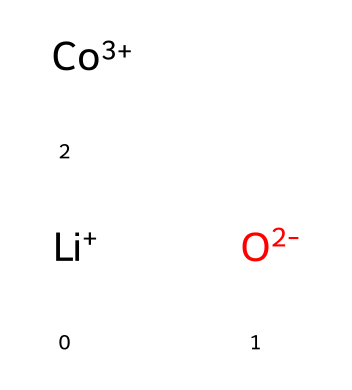What is the total charge of lithium cobalt oxide? The chemical representation indicates lithium as Li+ (1+), cobalt as Co+3 (3+), and oxygen as O-2 (2-). Therefore, the total charge calculation is: 1 + 3 - 2 = 2.
Answer: 2 How many lithium atoms are present in the structure? The SMILES representation indicates one lithium ion [Li+], meaning there is one lithium atom in the structure.
Answer: 1 What type of bonding is primarily present in lithium cobalt oxide? The chemical structure suggests ionic bonding due to the presence of charged ions (Li+, Co+3, and O-2), which typically undergo ionic interactions.
Answer: ionic What is the coordination number of cobalt in lithium cobalt oxide? Cobalt typically coordinates with oxygen atoms due to its positive charge. In this structure, cobalt likely engages with several oxygen ions, which gives it a coordination number of 6.
Answer: 6 How many oxygen atoms are involved in the crystal lattice? The SMILES notation indicates there are two oxygen ions represented by [O-2], which directly shows the number of oxygen atoms in the structure.
Answer: 2 